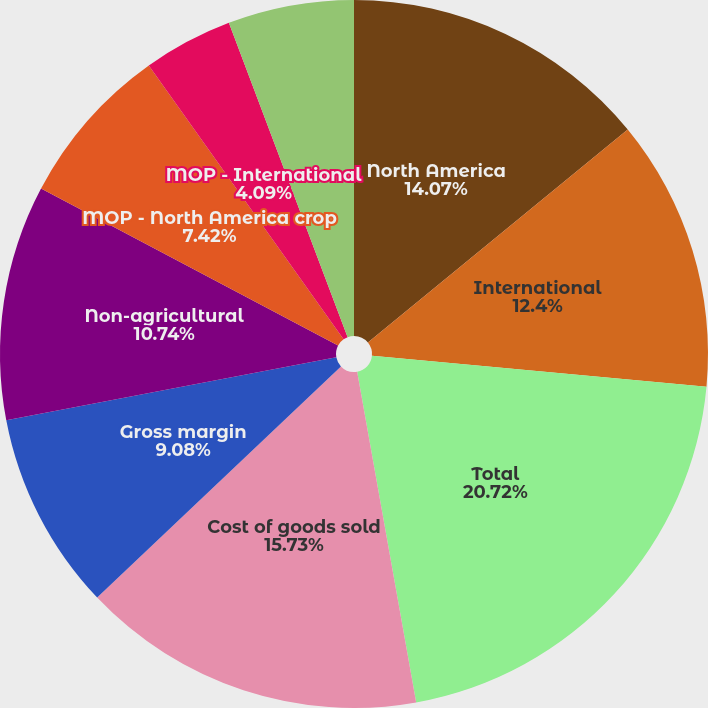Convert chart. <chart><loc_0><loc_0><loc_500><loc_500><pie_chart><fcel>North America<fcel>International<fcel>Total<fcel>Cost of goods sold<fcel>Gross margin<fcel>Non-agricultural<fcel>MOP - North America crop<fcel>MOP - International<fcel>MOP - Average^(b)<nl><fcel>14.07%<fcel>12.4%<fcel>20.72%<fcel>15.73%<fcel>9.08%<fcel>10.74%<fcel>7.42%<fcel>4.09%<fcel>5.75%<nl></chart> 